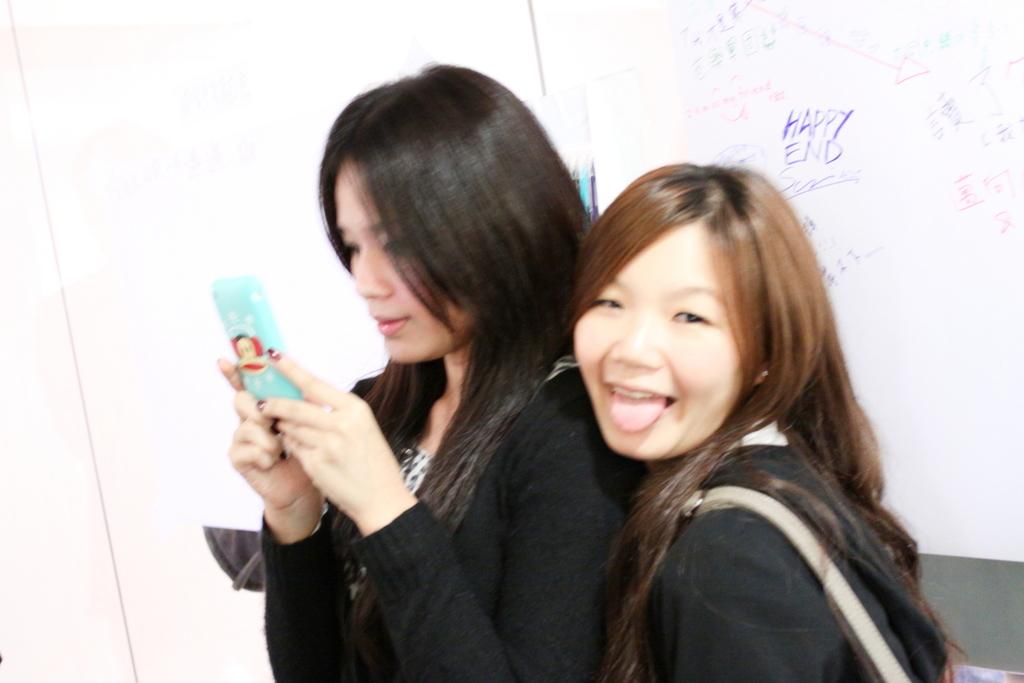How many women are in the image? There are two women in the image. What are the women wearing? The women are wearing black dresses. What can be seen in the background of the image? There is a board with text on it in the background. How did the women attempt to escape the rainstorm in the image? There is no rainstorm present in the image, and therefore no attempt to escape it can be observed. 